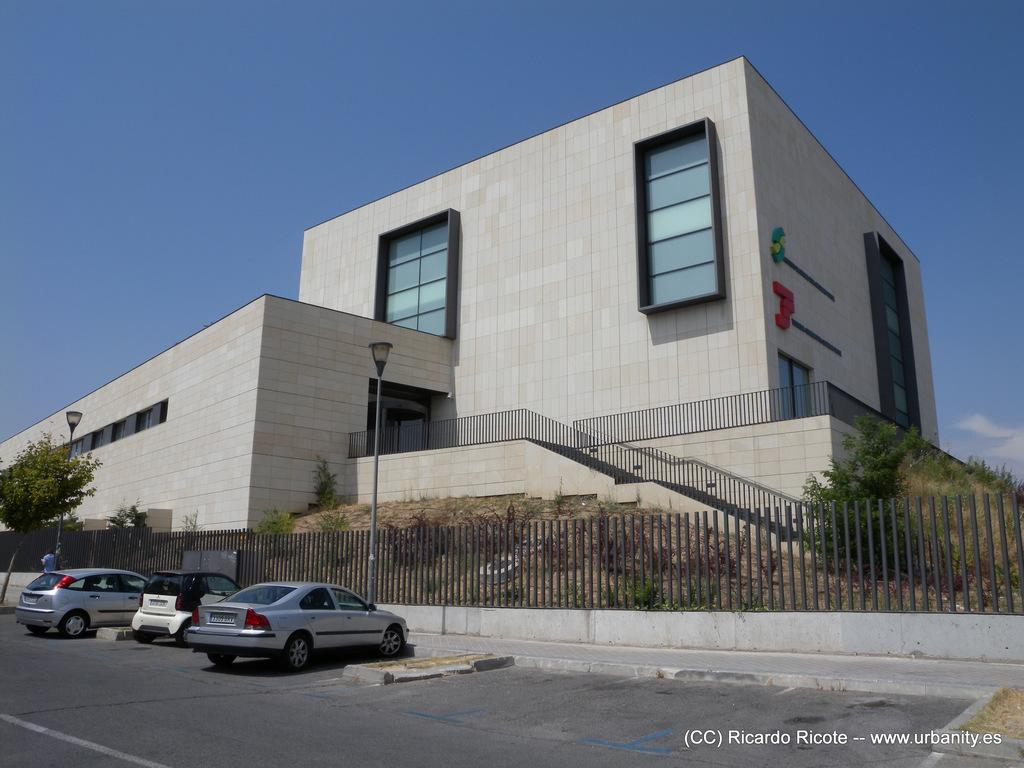What can be found in the bottom right corner of the image? There is a watermark in the bottom right corner of the image. Where are the vehicles located in the image? The vehicles are parked on the left side of the image. What surface are the vehicles on? The vehicles are on a road. What can be seen in the background of the image? There are trees, plants, poles, a building, and the sky visible in the background of the image. What type of lettuce is being cut with a knife in the image? There is no lettuce or knife present in the image. What is the visibility like in the image due to the mist? There is no mist present in the image, so it cannot affect visibility. 